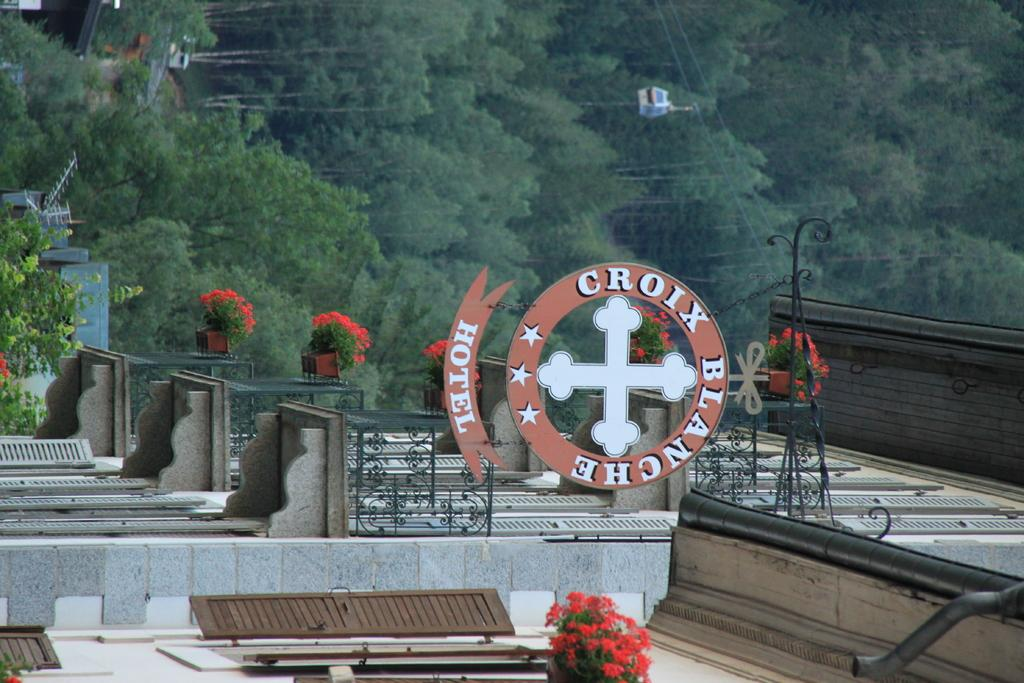What type of structure is in the image? There is a building in the image. What is attached to the building? A board is attached to the building. What can be seen in the background of the image? Trees are visible at the top of the image. What else is present in the image? Wires are present in the image. Where can someone find advice in the image? There is no indication of advice being offered or sought in the image. Is there a lunchroom in the image? There is no mention of a lunchroom in the image. Can you see any berries in the image? There are no berries visible in the image. 